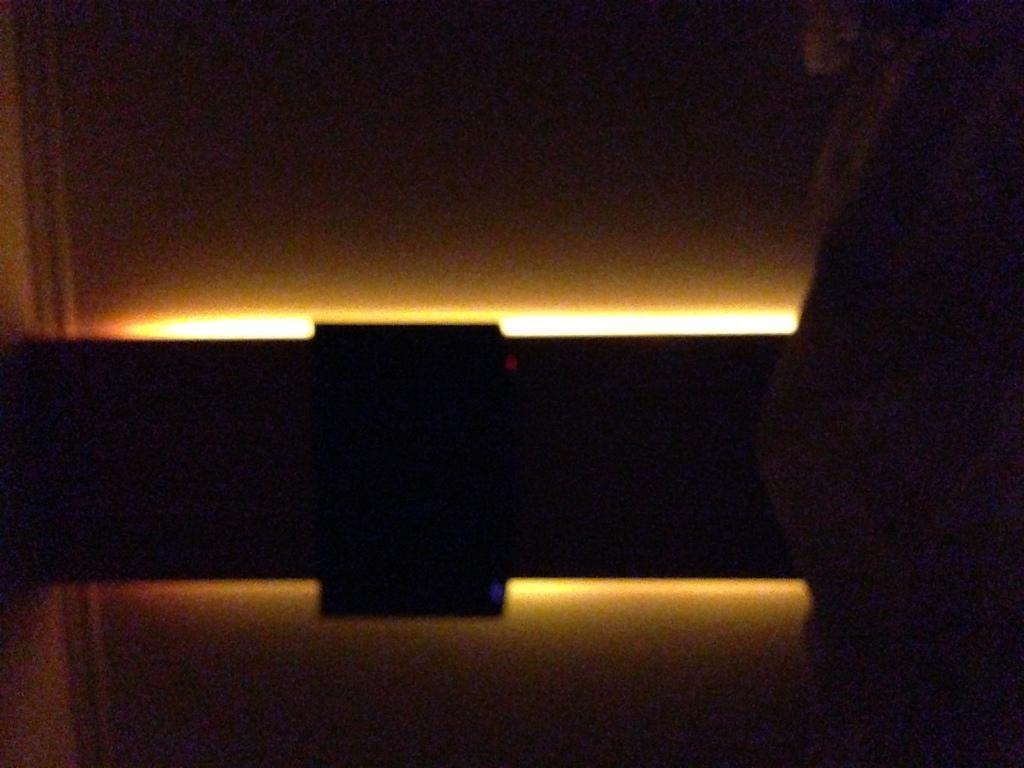What is the color of the objects in the image? The objects in the image are black in color. What can be seen in the middle of the image? There is a light in the middle of the image. What is visible in the background of the image? There is a wall visible in the background of the image. What type of paste is being used to fix the appliance in the image? There is no appliance or paste present in the image; it only features black objects and a light. 